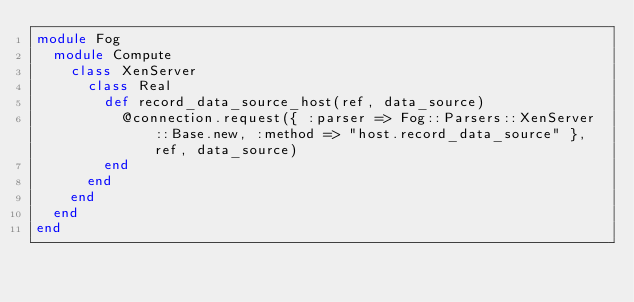Convert code to text. <code><loc_0><loc_0><loc_500><loc_500><_Ruby_>module Fog
  module Compute
    class XenServer
      class Real
        def record_data_source_host(ref, data_source)
          @connection.request({ :parser => Fog::Parsers::XenServer::Base.new, :method => "host.record_data_source" }, ref, data_source)
        end
      end
    end
  end
end
</code> 